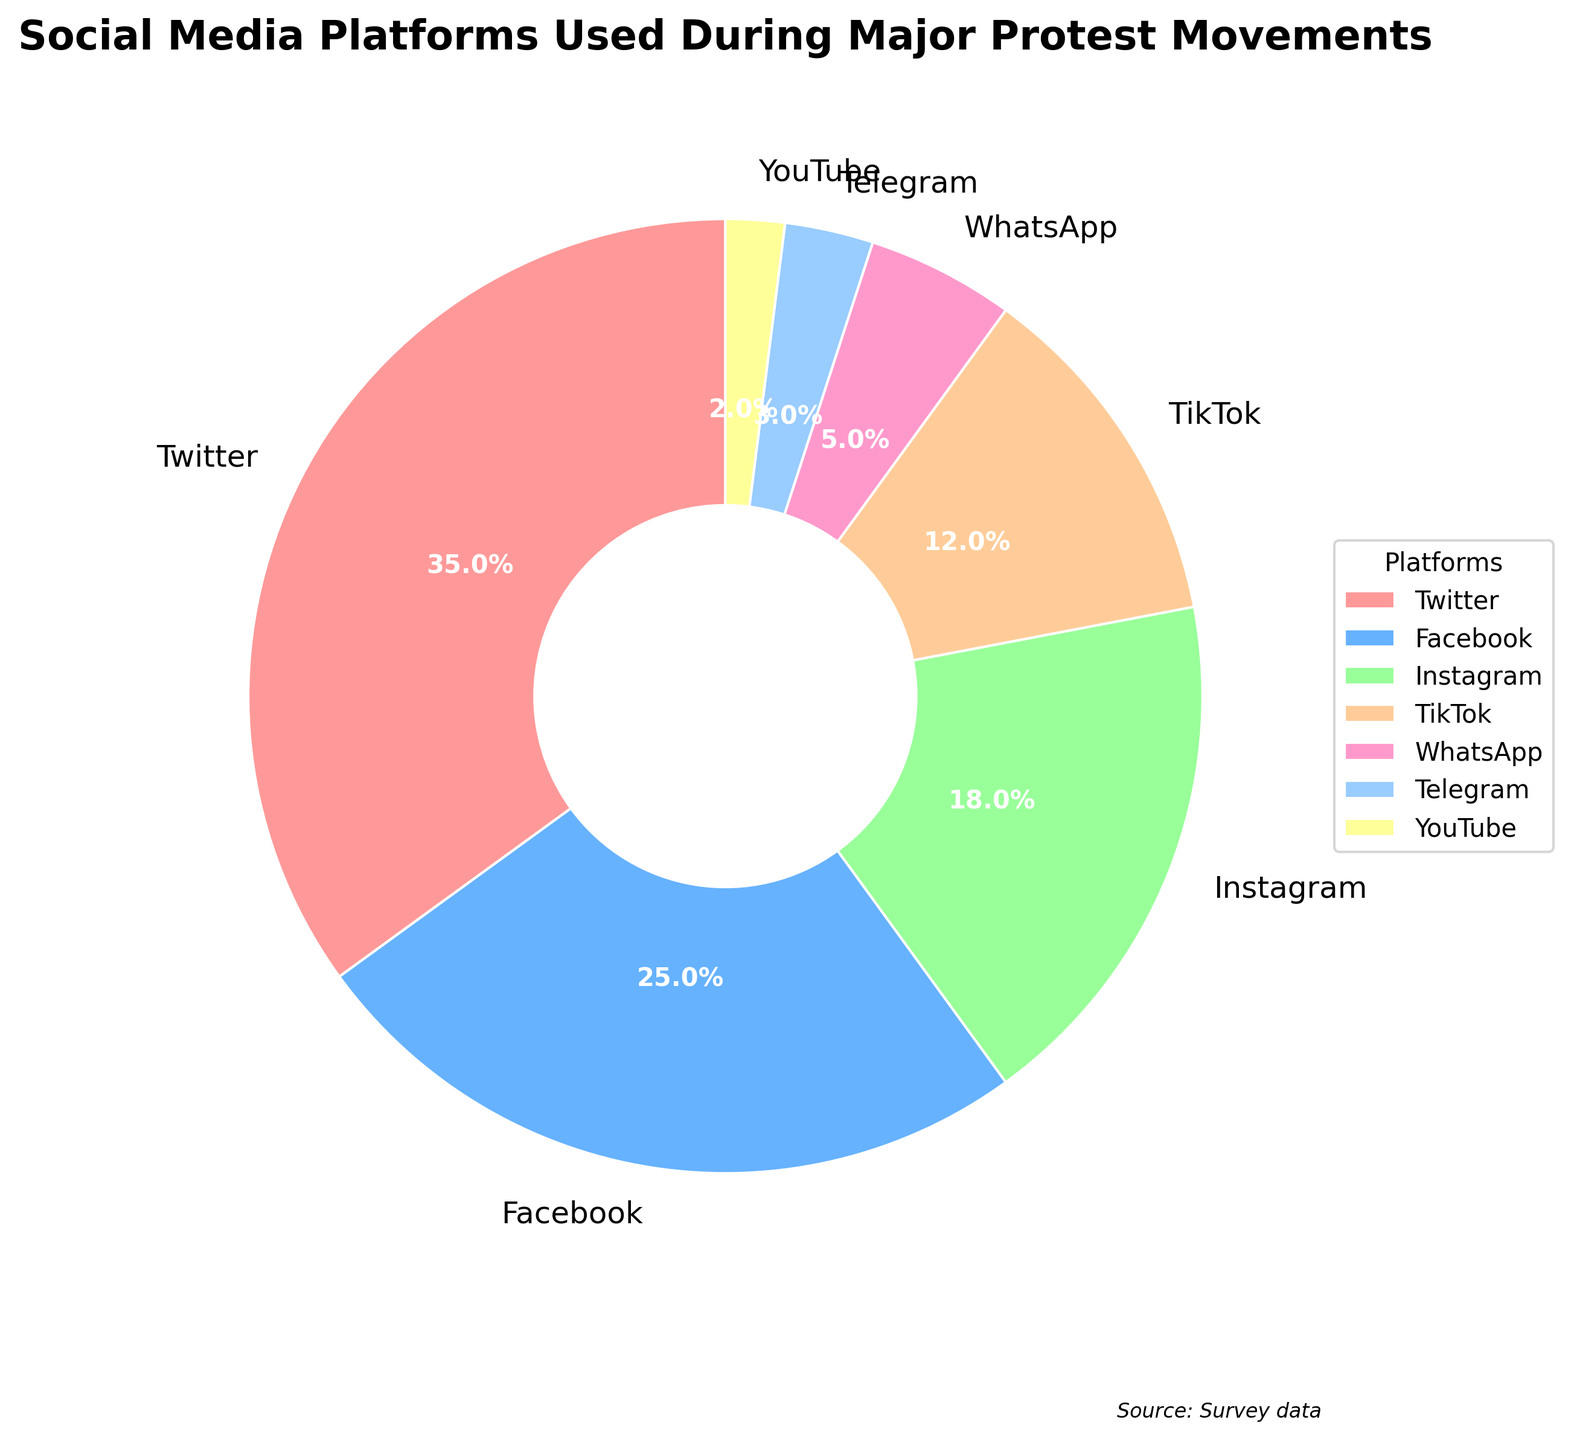What percentage of the platforms are used by less than 10% of participants? There are three platforms with less than 10% usage: WhatsApp (5%), Telegram (3%), and YouTube (2%). Adding these percentages together: 5% + 3% + 2% = 10%.
Answer: 10% Which platform is the most used during major protest movements? The segment with 35% is labeled as Twitter, which is the highest percentage in the pie chart.
Answer: Twitter How much more popular is Facebook than Telegram? Facebook has 25% and Telegram has 3%. The difference is calculated as 25% - 3% = 22%.
Answer: 22% Is Instagram more widely used than TikTok and WhatsApp combined? Instagram has 18%, TikTok has 12%, and WhatsApp has 5%. Adding TikTok and WhatsApp: 12% + 5% = 17%. Since 18% > 17%, Instagram is more widely used.
Answer: Yes What is the second least used platform? The least used platform is YouTube with 2%. The second least used is Telegram with 3%.
Answer: Telegram Which platforms together make up more than half (over 50%) of the usage? Adding the percentages from the largest down until we exceed 50%: Twitter (35%) + Facebook (25%) = 60%. Since 60% > 50%, Twitter and Facebook together constitute more than half.
Answer: Twitter and Facebook What is the total percentage of use for the platforms Facebook, Instagram, and TikTok? Facebook has 25%, Instagram has 18%, and TikTok has 12%. Adding these together: 25% + 18% + 12% = 55%.
Answer: 55% Which two platforms have the closest usage percentages? TikTok has 12% and WhatsApp has 5%, making a difference of 7%. Comparing all combinations, TikTok and WhatsApp pair shows the least difference.
Answer: TikTok and WhatsApp 